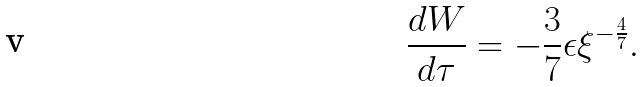<formula> <loc_0><loc_0><loc_500><loc_500>\frac { d W } { d \tau } = - \frac { 3 } { 7 } \epsilon \xi ^ { - \frac { 4 } { 7 } } .</formula> 